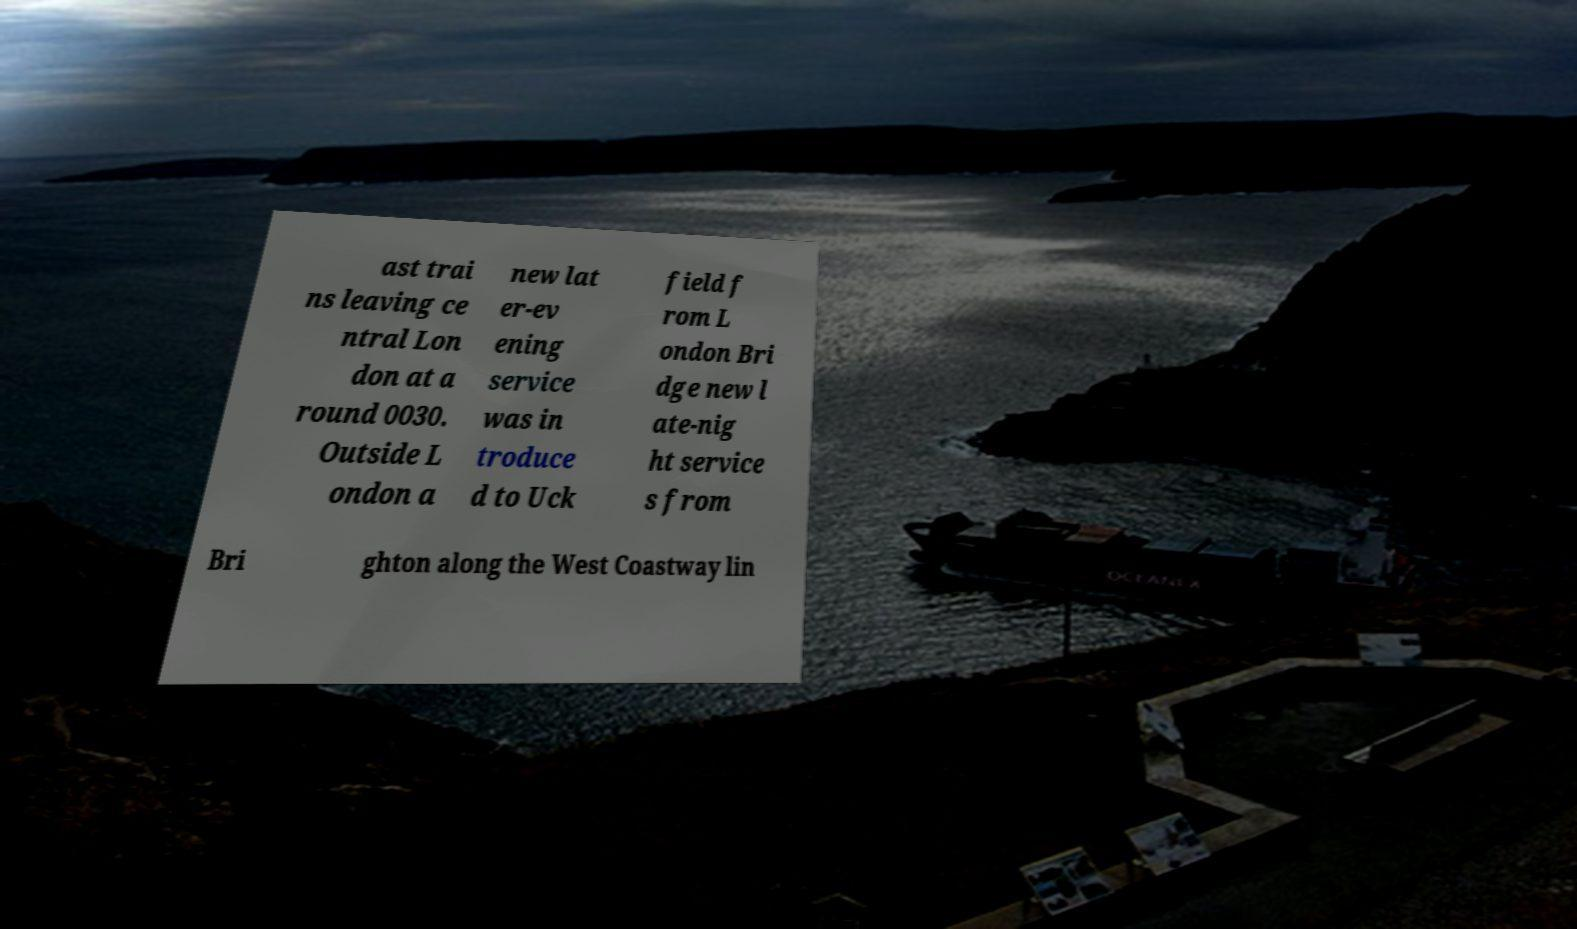I need the written content from this picture converted into text. Can you do that? ast trai ns leaving ce ntral Lon don at a round 0030. Outside L ondon a new lat er-ev ening service was in troduce d to Uck field f rom L ondon Bri dge new l ate-nig ht service s from Bri ghton along the West Coastway lin 